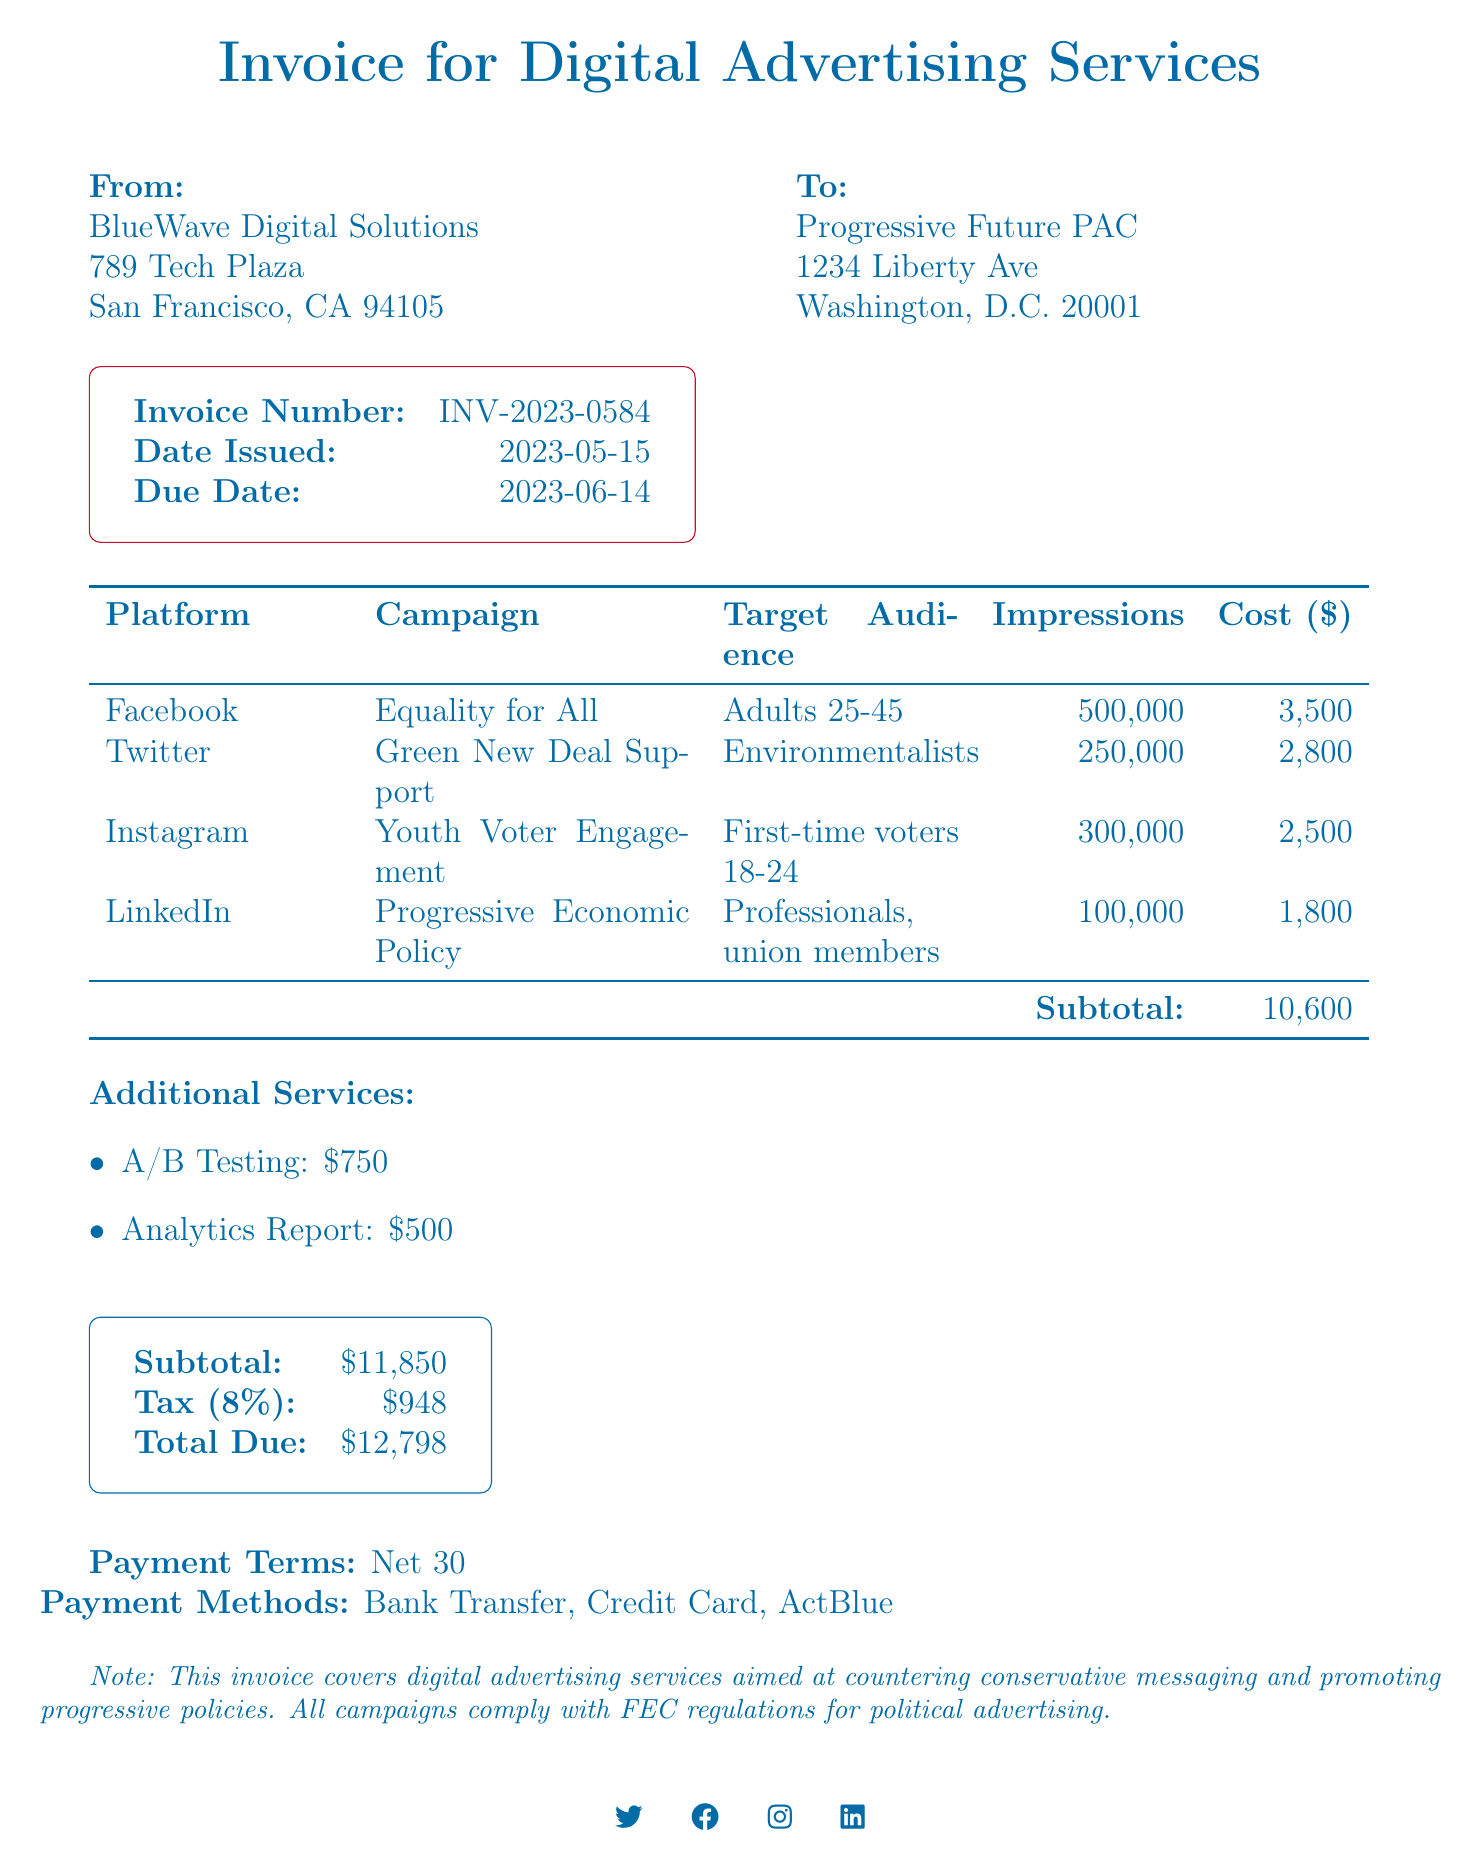What is the invoice number? The invoice number is explicitly mentioned at the top of the document as INV-2023-0584.
Answer: INV-2023-0584 Who is the service provider? The service provider's name is located in the section indicating the sender of the invoice, which is BlueWave Digital Solutions.
Answer: BlueWave Digital Solutions What is the total due amount? The total amount owed is provided in a clear format at the bottom of the document as 12,798.
Answer: 12,798 How many impressions are targeted in the "Equality for All" campaign? The number of impressions for the "Equality for All" campaign is stated explicitly within the campaign details section as 500,000.
Answer: 500,000 What is the duration of the "Youth Voter Engagement" campaign? The duration is indicated in the campaign details section, where it states that the campaign runs for 14 days.
Answer: 14 days What services are included in the additional services section? The additional services listed include A/B Testing and an Analytics Report.
Answer: A/B Testing, Analytics Report What is the subtotal before tax? The subtotal amount before tax is provided as a separate item in the document and totals 11,850.
Answer: 11,850 What is the tax rate applied to the invoice? The tax rate is clearly mentioned as 8% in the subtotal section of the invoice.
Answer: 8% 